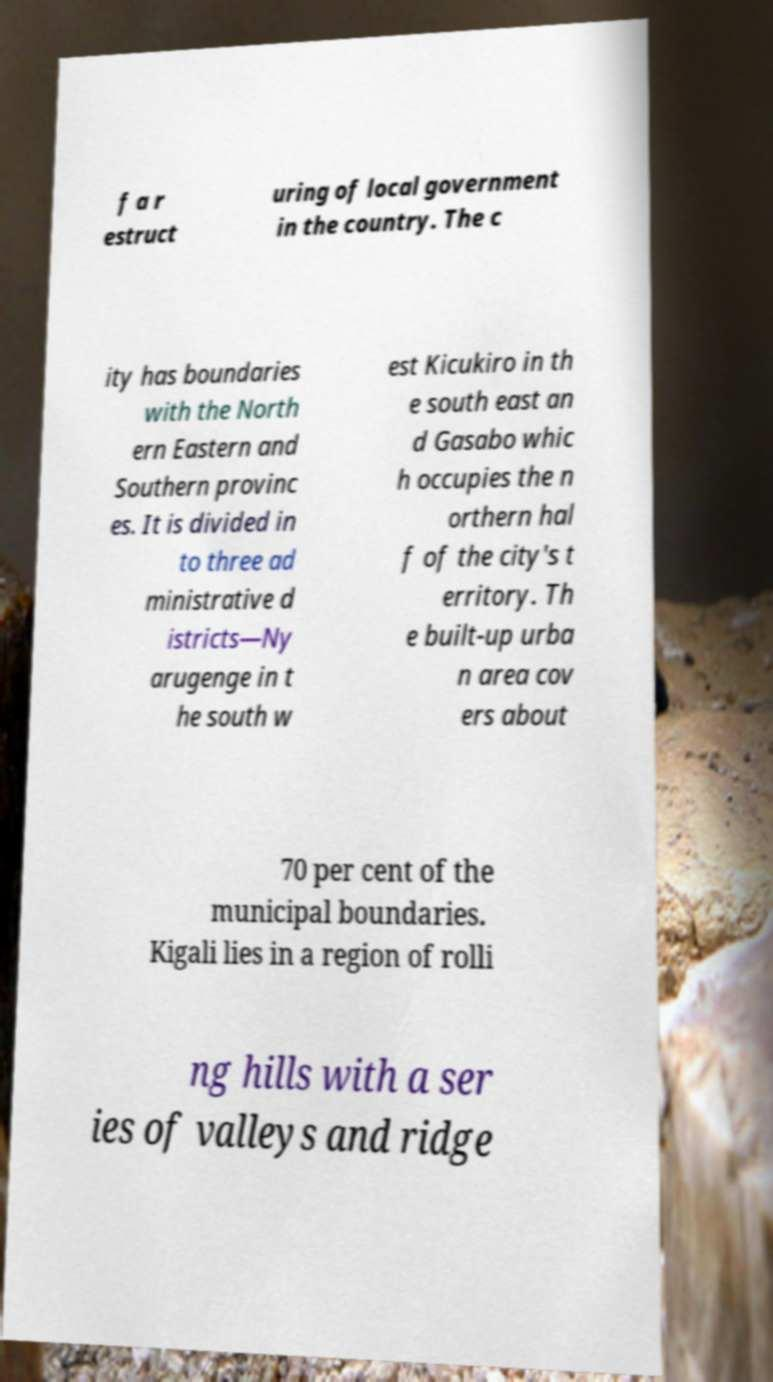Please read and relay the text visible in this image. What does it say? f a r estruct uring of local government in the country. The c ity has boundaries with the North ern Eastern and Southern provinc es. It is divided in to three ad ministrative d istricts—Ny arugenge in t he south w est Kicukiro in th e south east an d Gasabo whic h occupies the n orthern hal f of the city's t erritory. Th e built-up urba n area cov ers about 70 per cent of the municipal boundaries. Kigali lies in a region of rolli ng hills with a ser ies of valleys and ridge 